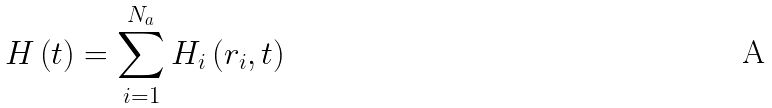Convert formula to latex. <formula><loc_0><loc_0><loc_500><loc_500>H \left ( t \right ) = \sum _ { i = 1 } ^ { N _ { a } } H _ { i } \left ( { r } _ { i } , t \right )</formula> 